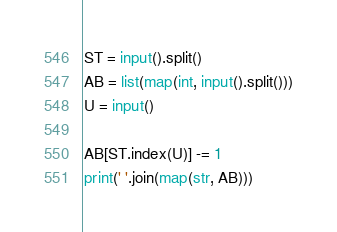<code> <loc_0><loc_0><loc_500><loc_500><_Python_>ST = input().split()
AB = list(map(int, input().split()))
U = input()

AB[ST.index(U)] -= 1
print(' '.join(map(str, AB)))
</code> 